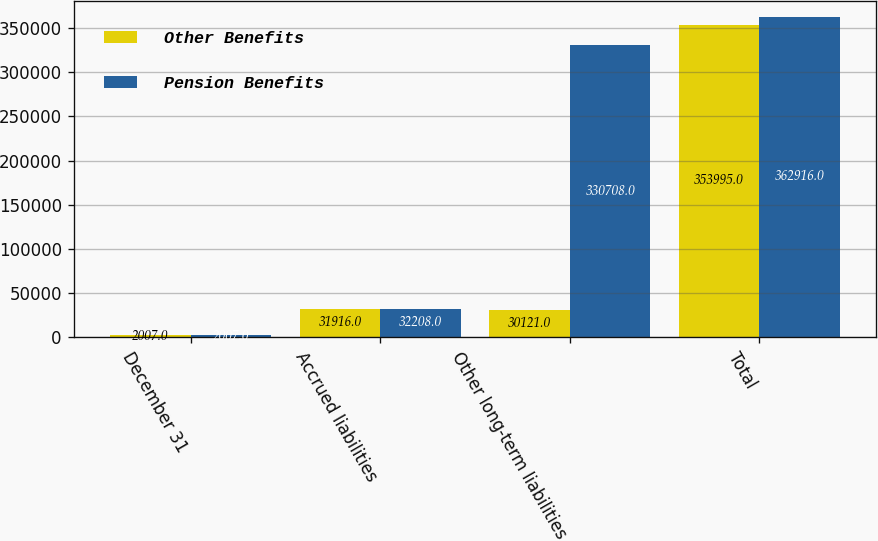Convert chart to OTSL. <chart><loc_0><loc_0><loc_500><loc_500><stacked_bar_chart><ecel><fcel>December 31<fcel>Accrued liabilities<fcel>Other long-term liabilities<fcel>Total<nl><fcel>Other Benefits<fcel>2007<fcel>31916<fcel>30121<fcel>353995<nl><fcel>Pension Benefits<fcel>2007<fcel>32208<fcel>330708<fcel>362916<nl></chart> 